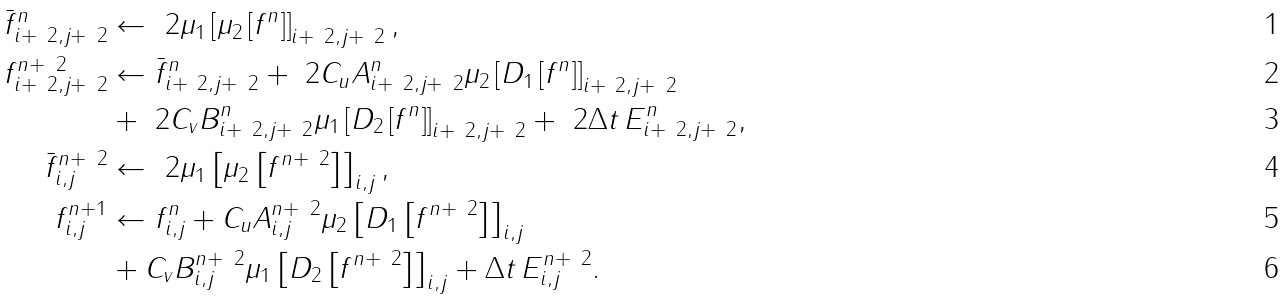<formula> <loc_0><loc_0><loc_500><loc_500>\bar { f } ^ { n } _ { i + \ 2 , j + \ 2 } & \leftarrow \ 2 \mu _ { 1 } \left [ \mu _ { 2 } \left [ f ^ { n } \right ] \right ] _ { i + \ 2 , j + \ 2 } , \\ f ^ { n + \ 2 } _ { i + \ 2 , j + \ 2 } & \leftarrow \bar { f } ^ { n } _ { i + \ 2 , j + \ 2 } + \ 2 C _ { u } A ^ { n } _ { i + \ 2 , j + \ 2 } \mu _ { 2 } \left [ D _ { 1 } \left [ f ^ { n } \right ] \right ] _ { i + \ 2 , j + \ 2 } \\ & + \ 2 C _ { v } B ^ { n } _ { i + \ 2 , j + \ 2 } \mu _ { 1 } \left [ D _ { 2 } \left [ f ^ { n } \right ] \right ] _ { i + \ 2 , j + \ 2 } + \ 2 \Delta t \, E ^ { n } _ { i + \ 2 , j + \ 2 } , \\ \bar { f } ^ { n + \ 2 } _ { i , j } & \leftarrow \ 2 \mu _ { 1 } \left [ \mu _ { 2 } \left [ f ^ { n + \ 2 } \right ] \right ] _ { i , j } , \\ f ^ { n + 1 } _ { i , j } & \leftarrow f ^ { n } _ { i , j } + C _ { u } A ^ { n + \ 2 } _ { i , j } \mu _ { 2 } \left [ D _ { 1 } \left [ f ^ { n + \ 2 } \right ] \right ] _ { i , j } \\ & + C _ { v } B ^ { n + \ 2 } _ { i , j } \mu _ { 1 } \left [ D _ { 2 } \left [ f ^ { n + \ 2 } \right ] \right ] _ { i , j } + \Delta t \, E ^ { n + \ 2 } _ { i , j } .</formula> 